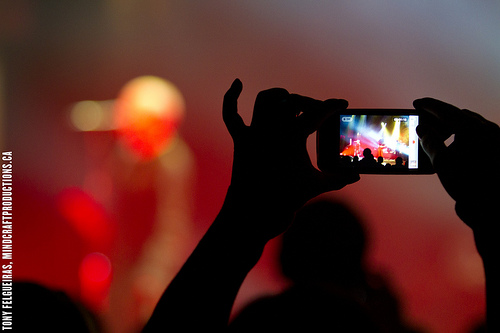<image>
Can you confirm if the singer is to the left of the camera? Yes. From this viewpoint, the singer is positioned to the left side relative to the camera. 